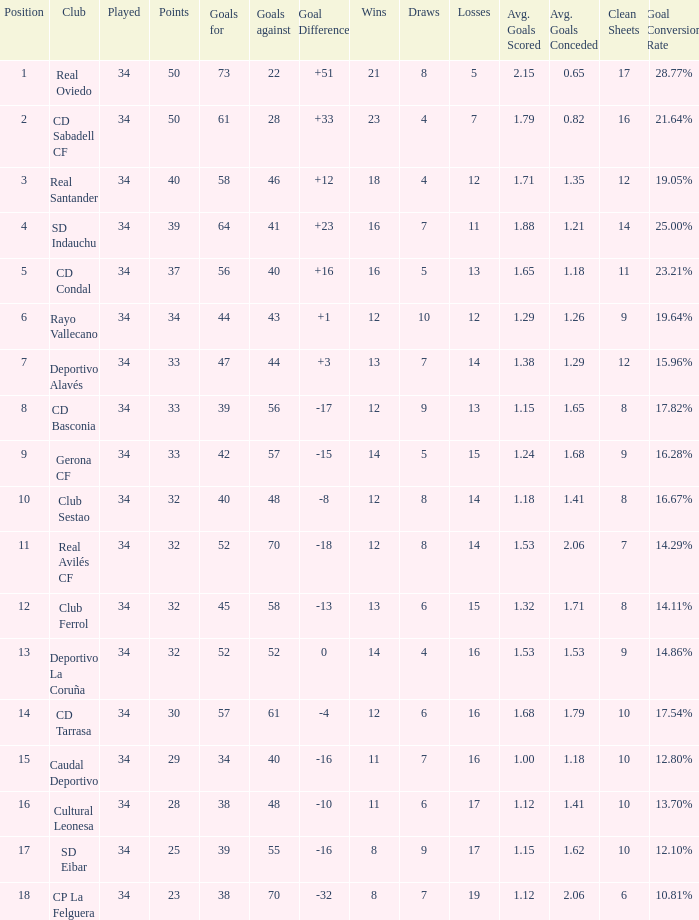Which Played has Draws smaller than 7, and Goals for smaller than 61, and Goals against smaller than 48, and a Position of 5? 34.0. 